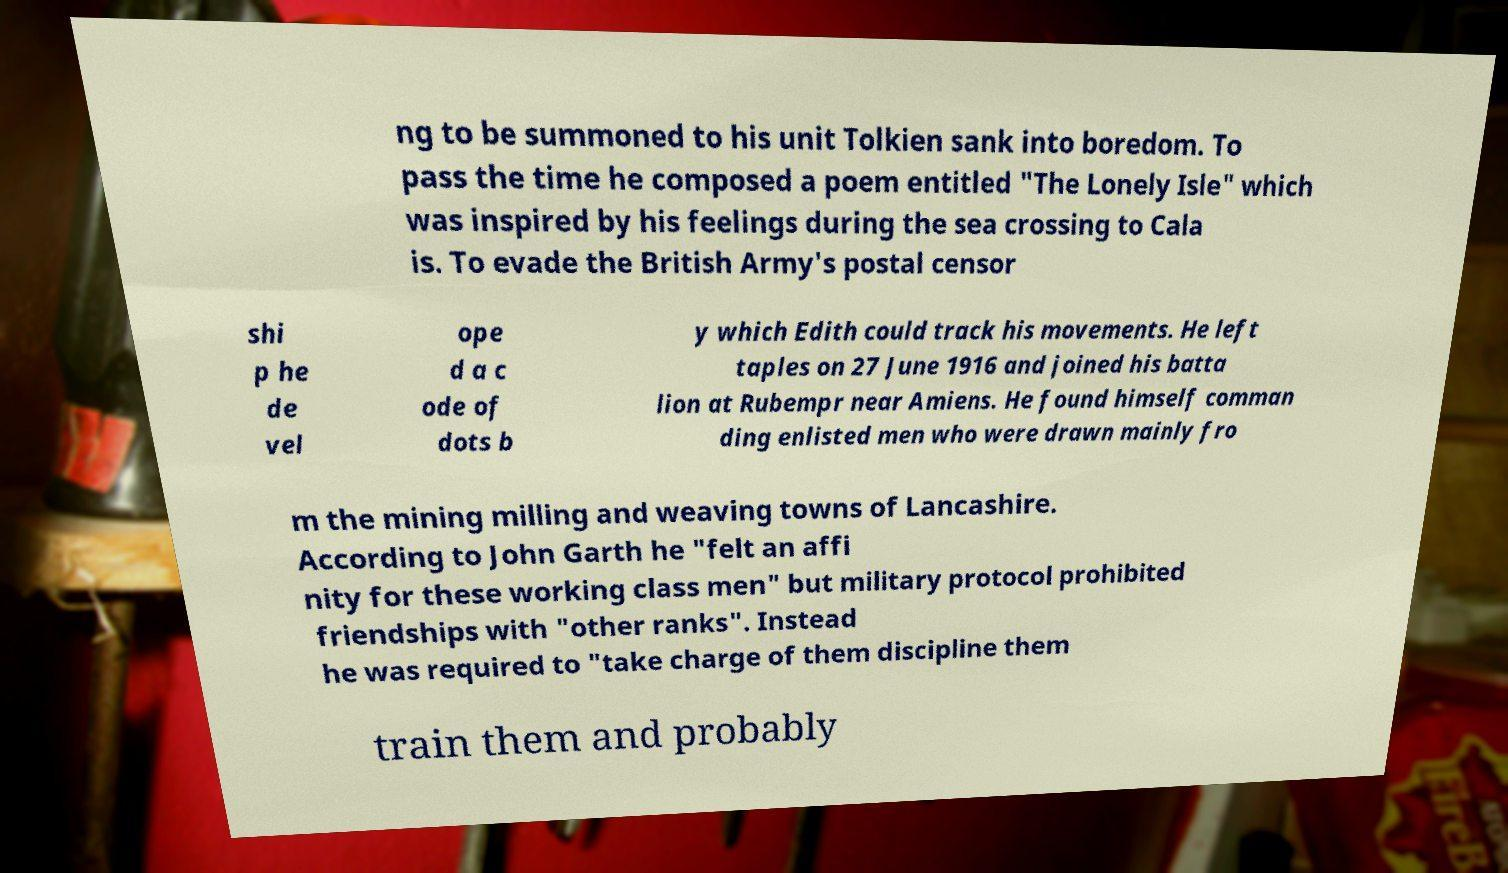Please read and relay the text visible in this image. What does it say? ng to be summoned to his unit Tolkien sank into boredom. To pass the time he composed a poem entitled "The Lonely Isle" which was inspired by his feelings during the sea crossing to Cala is. To evade the British Army's postal censor shi p he de vel ope d a c ode of dots b y which Edith could track his movements. He left taples on 27 June 1916 and joined his batta lion at Rubempr near Amiens. He found himself comman ding enlisted men who were drawn mainly fro m the mining milling and weaving towns of Lancashire. According to John Garth he "felt an affi nity for these working class men" but military protocol prohibited friendships with "other ranks". Instead he was required to "take charge of them discipline them train them and probably 